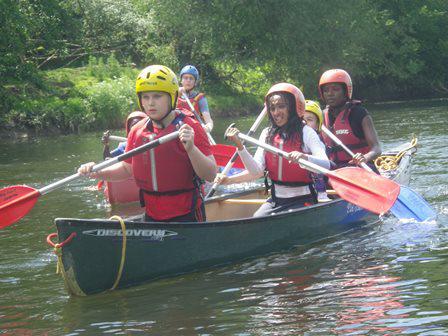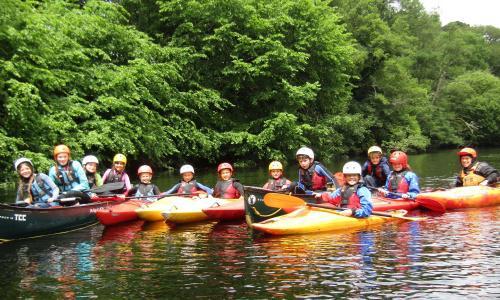The first image is the image on the left, the second image is the image on the right. Evaluate the accuracy of this statement regarding the images: "The left and right image contains a total of four boats.". Is it true? Answer yes or no. No. The first image is the image on the left, the second image is the image on the right. Evaluate the accuracy of this statement regarding the images: "An image includes a red canoe with three riders and no other canoe with a seated person in it.". Is it true? Answer yes or no. No. 